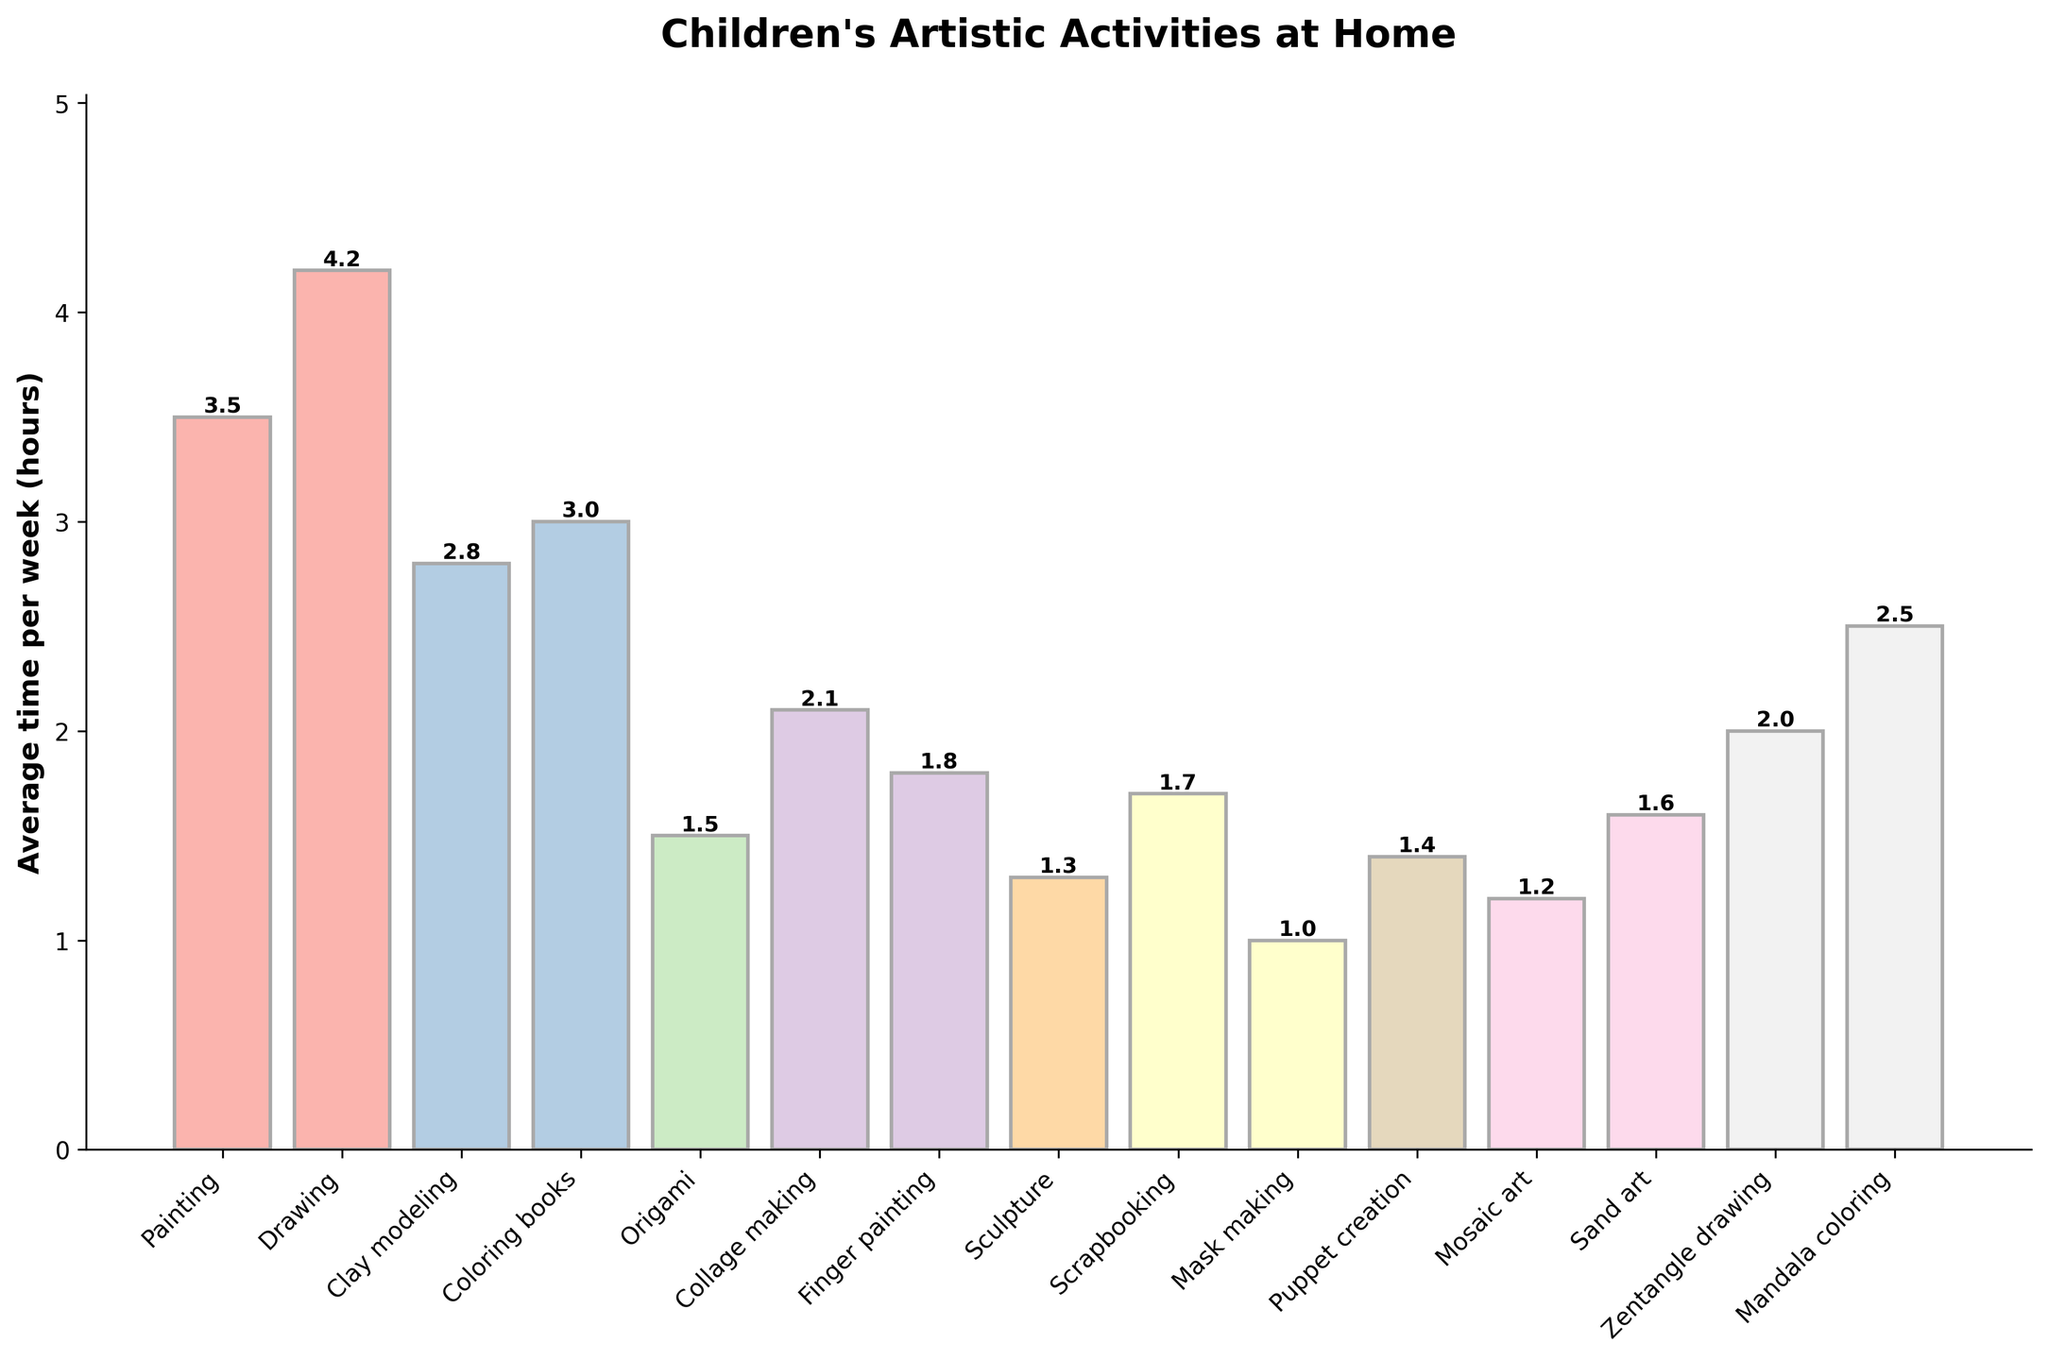What is the activity that children spent the most time on weekly? Looking at the figure, identify the tallest bar which represents the activity with the highest average time spent per week.
Answer: Drawing How much more time do children spend on painting compared to sculpture each week? To find this, subtract the height of the bar representing sculpture from the height of the bar representing painting (3.5 - 1.3).
Answer: 2.2 hours What is the total time per week spent on collage making, finger painting, and scrapbooking? Add the heights of the bars representing these activities: 2.1 for collage making, 1.8 for finger painting, and 1.7 for scrapbooking (2.1 + 1.8 + 1.7).
Answer: 5.6 hours Which two activities have the closest average time spent per week, and what are their times? Look for bars with similar heights, in this case, sand art and scrapbooking. Both have the closest values: sand art (1.6) and scrapbooking (1.7).
Answer: Sand art: 1.6 hours, Scrapbooking: 1.7 hours What is the difference in average time spent per week between the activity with the highest and the activity with the lowest time? Identify the highest (Drawing at 4.2) and lowest (Mask making at 1.0) bars, then subtract the lowest's height from the highest's height (4.2 - 1.0).
Answer: 3.2 hours On average, how much time is spent on painting and mandala coloring combined per week? Sum the heights of the bars for painting (3.5) and mandala coloring (2.5) (3.5 + 2.5).
Answer: 6.0 hours Which activity do children spend almost twice as much time on as origami? The height of the bar for origami is 1.5, and the bar closest to double this value is drawing with a height of 4.2. Validate by checking the near double value (1.5 * 2 is 3, and Drawing is indeed greater).
Answer: Drawing What is the average time per week spent on all activities shown? Find the sum of all bar heights and divide by the number of activities: Sum = 3.5 + 4.2 + 2.8 + 3.0 + 1.5 + 2.1 + 1.8 + 1.3 + 1.7 + 1.0 + 1.4 + 1.2 + 1.6 + 2.0 + 2.5 = 31.6. There are 15 activities, so 31.6/15.
Answer: 2.1 hours 